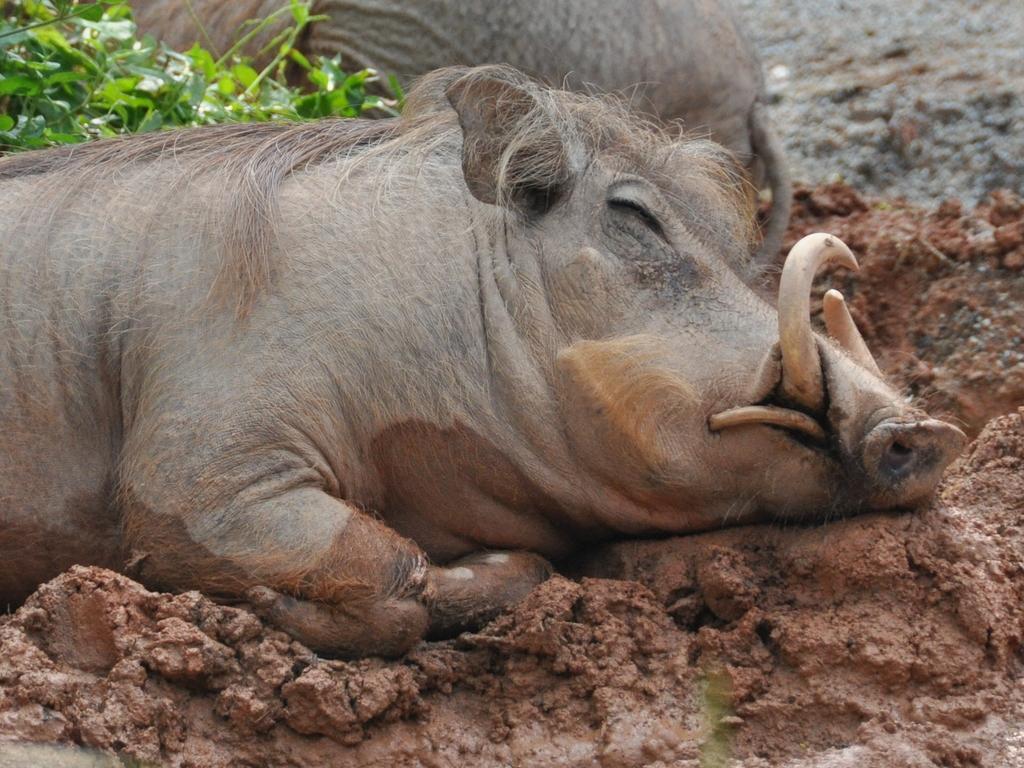Can you describe this image briefly? In this image we can see a boar lying on the mud. We can also see some plants. 